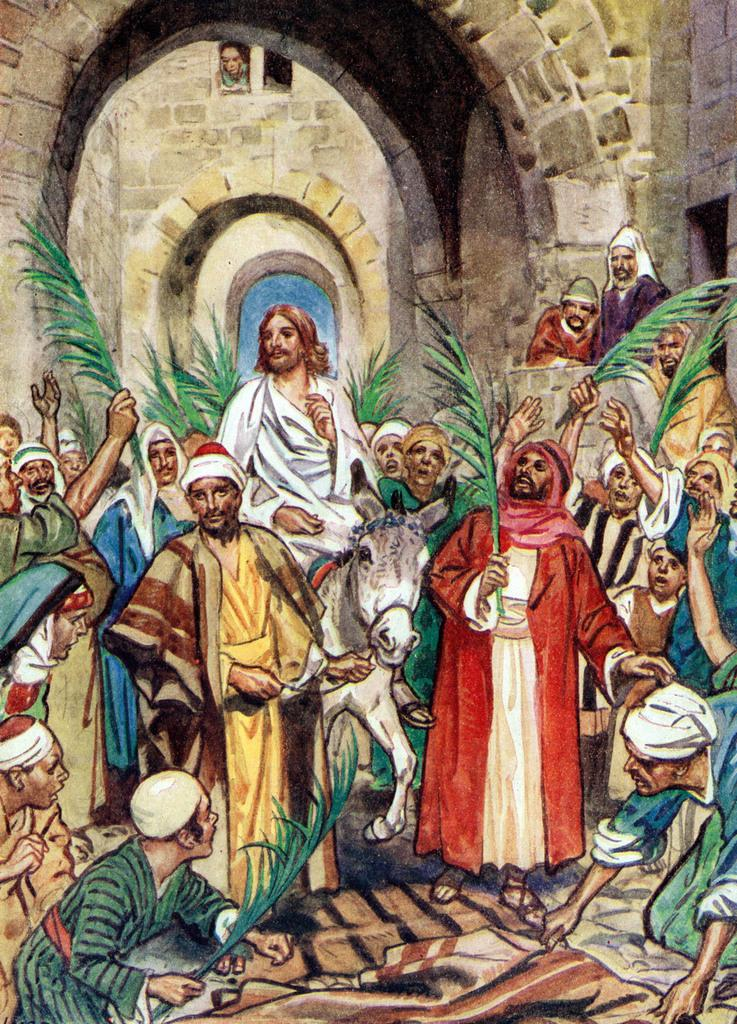What is: What is the main subject of the painting? The main subject of the painting is a group of people. Where are the people located in the painting? The people are standing on a road in the painting. Are there any animals present in the painting? Yes, there is a donkey in the painting. What other elements can be seen in the painting? Cloth and plants are depicted in the painting. What can be seen in the background of the painting? There is a building and an entrance visible in the background. Can you tell me how many tigers are chasing the people in the painting? There are no tigers present in the painting; it features a group of people, a donkey, and various other elements. What type of bait is being used to attract the eye in the painting? There is no bait or any element specifically designed to attract the eye in the painting. 